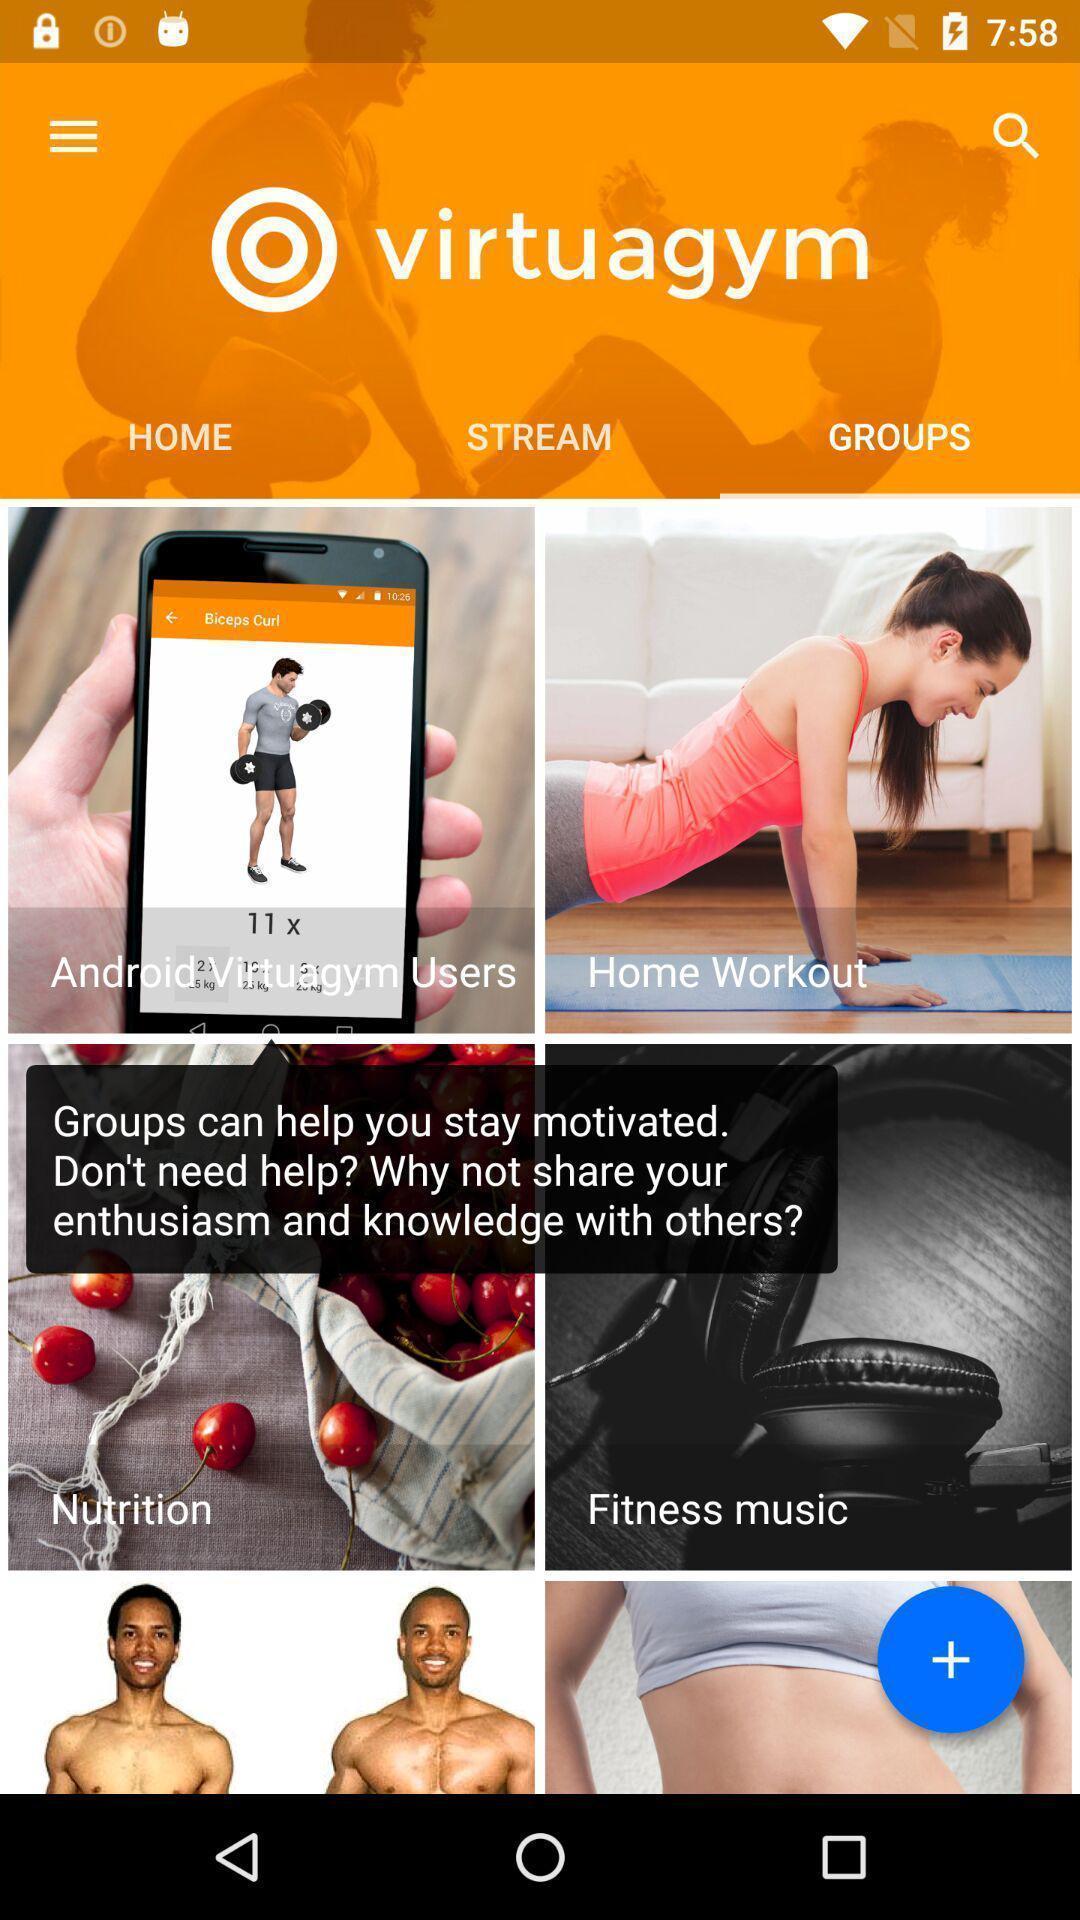Provide a textual representation of this image. Starting page. 